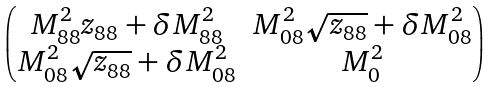<formula> <loc_0><loc_0><loc_500><loc_500>\begin{pmatrix} M _ { 8 8 } ^ { 2 } z _ { 8 8 } + \delta M ^ { 2 } _ { 8 8 } & M ^ { 2 } _ { 0 8 } \sqrt { z _ { 8 8 } } + \delta M ^ { 2 } _ { 0 8 } \\ M ^ { 2 } _ { 0 8 } \sqrt { z _ { 8 8 } } + \delta M ^ { 2 } _ { 0 8 } & M _ { 0 } ^ { 2 } \end{pmatrix}</formula> 